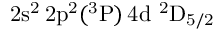Convert formula to latex. <formula><loc_0><loc_0><loc_500><loc_500>2 s ^ { 2 } \, 2 p ^ { 2 } ( ^ { 3 } P ) \, 4 d ^ { 2 } D _ { 5 / 2 }</formula> 